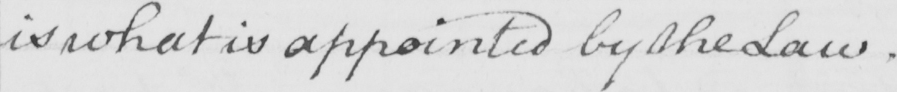Please provide the text content of this handwritten line. is what is appointed by the Law . 